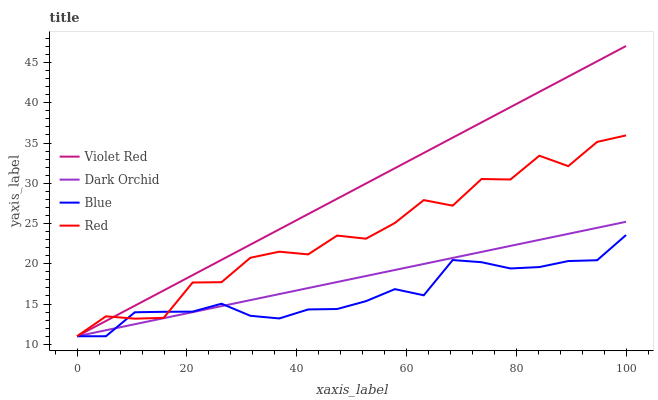Does Blue have the minimum area under the curve?
Answer yes or no. Yes. Does Violet Red have the maximum area under the curve?
Answer yes or no. Yes. Does Red have the minimum area under the curve?
Answer yes or no. No. Does Red have the maximum area under the curve?
Answer yes or no. No. Is Dark Orchid the smoothest?
Answer yes or no. Yes. Is Red the roughest?
Answer yes or no. Yes. Is Violet Red the smoothest?
Answer yes or no. No. Is Violet Red the roughest?
Answer yes or no. No. Does Violet Red have the highest value?
Answer yes or no. Yes. Does Red have the highest value?
Answer yes or no. No. Does Dark Orchid intersect Violet Red?
Answer yes or no. Yes. Is Dark Orchid less than Violet Red?
Answer yes or no. No. Is Dark Orchid greater than Violet Red?
Answer yes or no. No. 